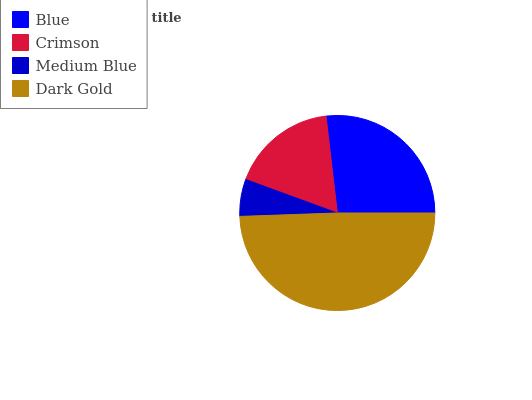Is Medium Blue the minimum?
Answer yes or no. Yes. Is Dark Gold the maximum?
Answer yes or no. Yes. Is Crimson the minimum?
Answer yes or no. No. Is Crimson the maximum?
Answer yes or no. No. Is Blue greater than Crimson?
Answer yes or no. Yes. Is Crimson less than Blue?
Answer yes or no. Yes. Is Crimson greater than Blue?
Answer yes or no. No. Is Blue less than Crimson?
Answer yes or no. No. Is Blue the high median?
Answer yes or no. Yes. Is Crimson the low median?
Answer yes or no. Yes. Is Medium Blue the high median?
Answer yes or no. No. Is Dark Gold the low median?
Answer yes or no. No. 